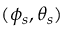<formula> <loc_0><loc_0><loc_500><loc_500>( \phi _ { s } , \theta _ { s } )</formula> 